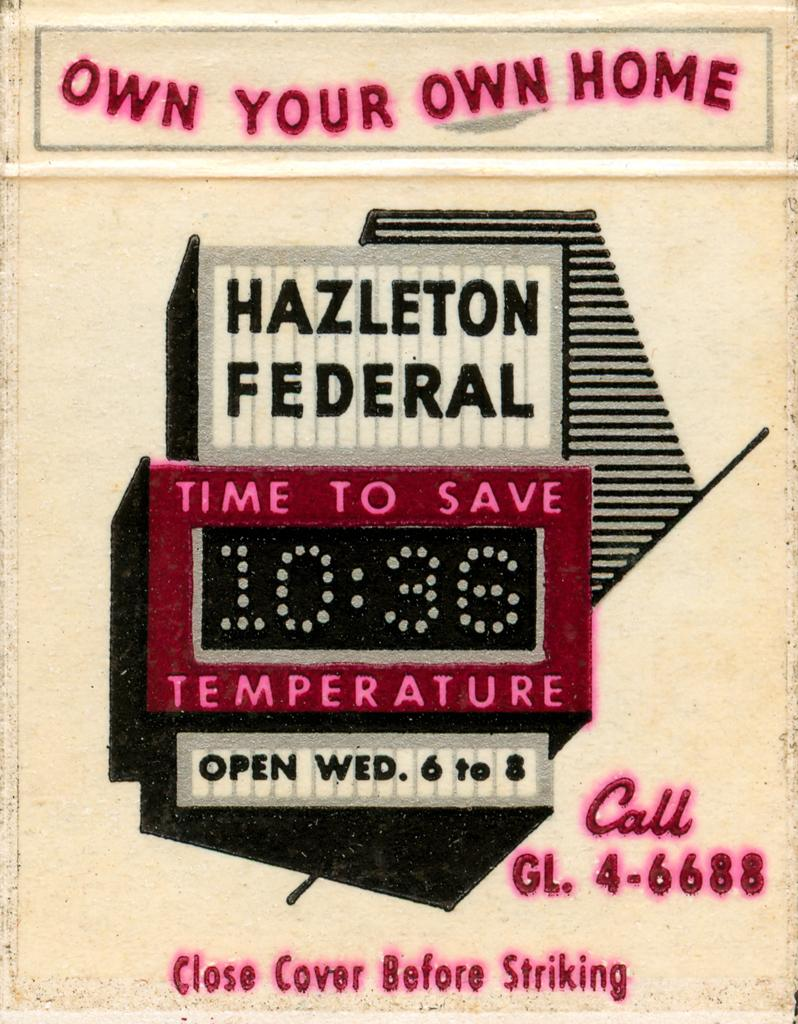Provide a one-sentence caption for the provided image. An advertisement for Hazleton Federal says the time is 10:36. 